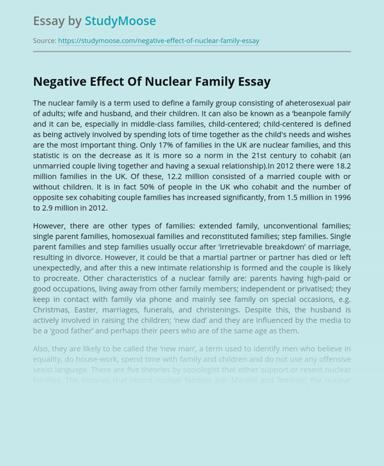Can you discuss the societal implications mentioned in the essay regarding the shift from nuclear to more diverse family structures? The essay highlights that this shift may influence broader societal structures, potentially leading to changes in social policy, legal frameworks, and community support systems. It suggests that as family structures diversify, there could be a greater need for flexible approaches to childcare, healthcare, and education to accommodate these non-traditional family units. 